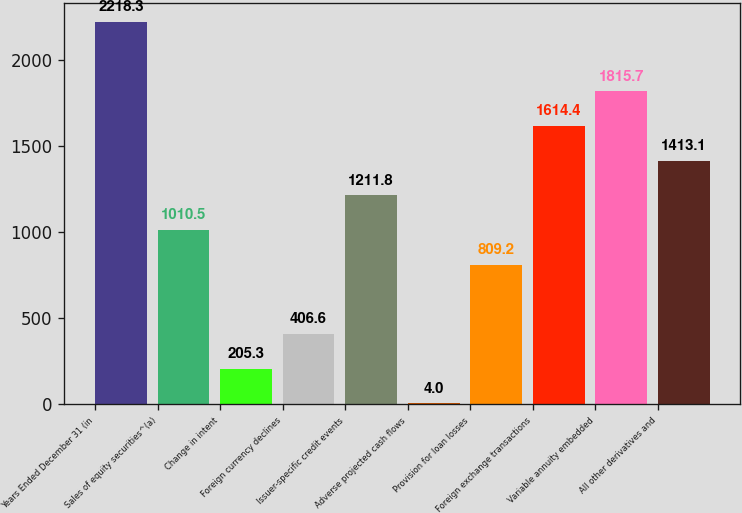<chart> <loc_0><loc_0><loc_500><loc_500><bar_chart><fcel>Years Ended December 31 (in<fcel>Sales of equity securities^(a)<fcel>Change in intent<fcel>Foreign currency declines<fcel>Issuer-specific credit events<fcel>Adverse projected cash flows<fcel>Provision for loan losses<fcel>Foreign exchange transactions<fcel>Variable annuity embedded<fcel>All other derivatives and<nl><fcel>2218.3<fcel>1010.5<fcel>205.3<fcel>406.6<fcel>1211.8<fcel>4<fcel>809.2<fcel>1614.4<fcel>1815.7<fcel>1413.1<nl></chart> 